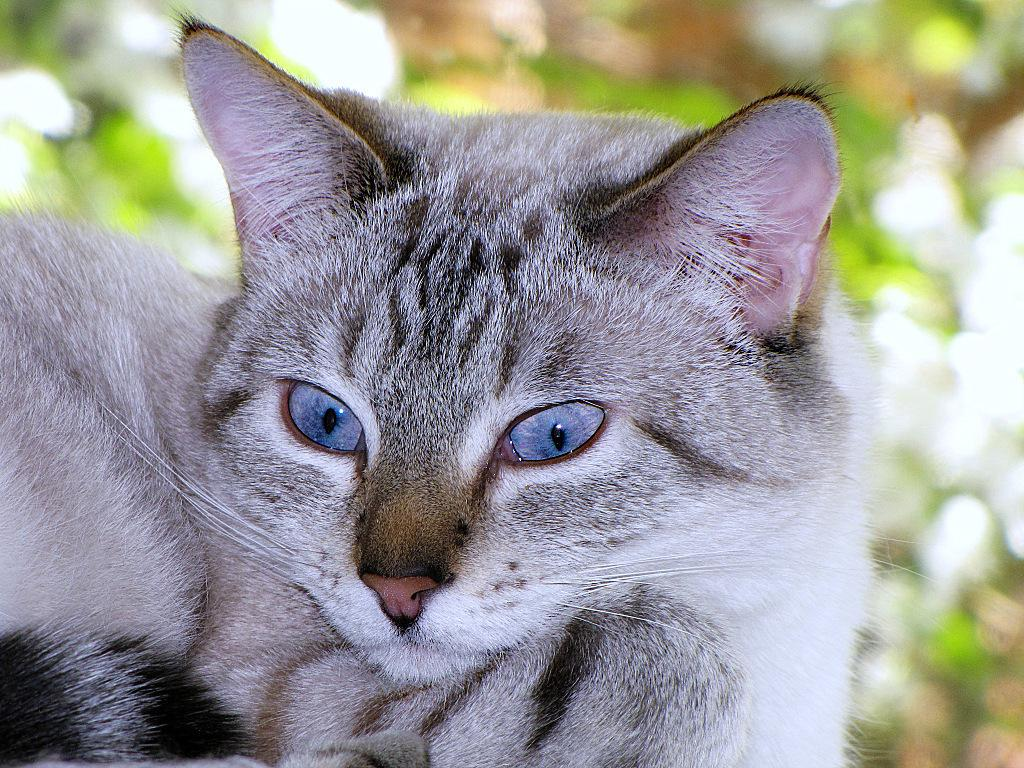What is the main subject of the image? There is a cat in the center of the image. Can you describe the background of the image? The background of the image is blurry. How many fish are swimming with the cat in the image? There are no fish present in the image; it features a cat and a blurry background. What type of underwear is the cat wearing in the image? Cats do not wear underwear, and there is no underwear present in the image. 